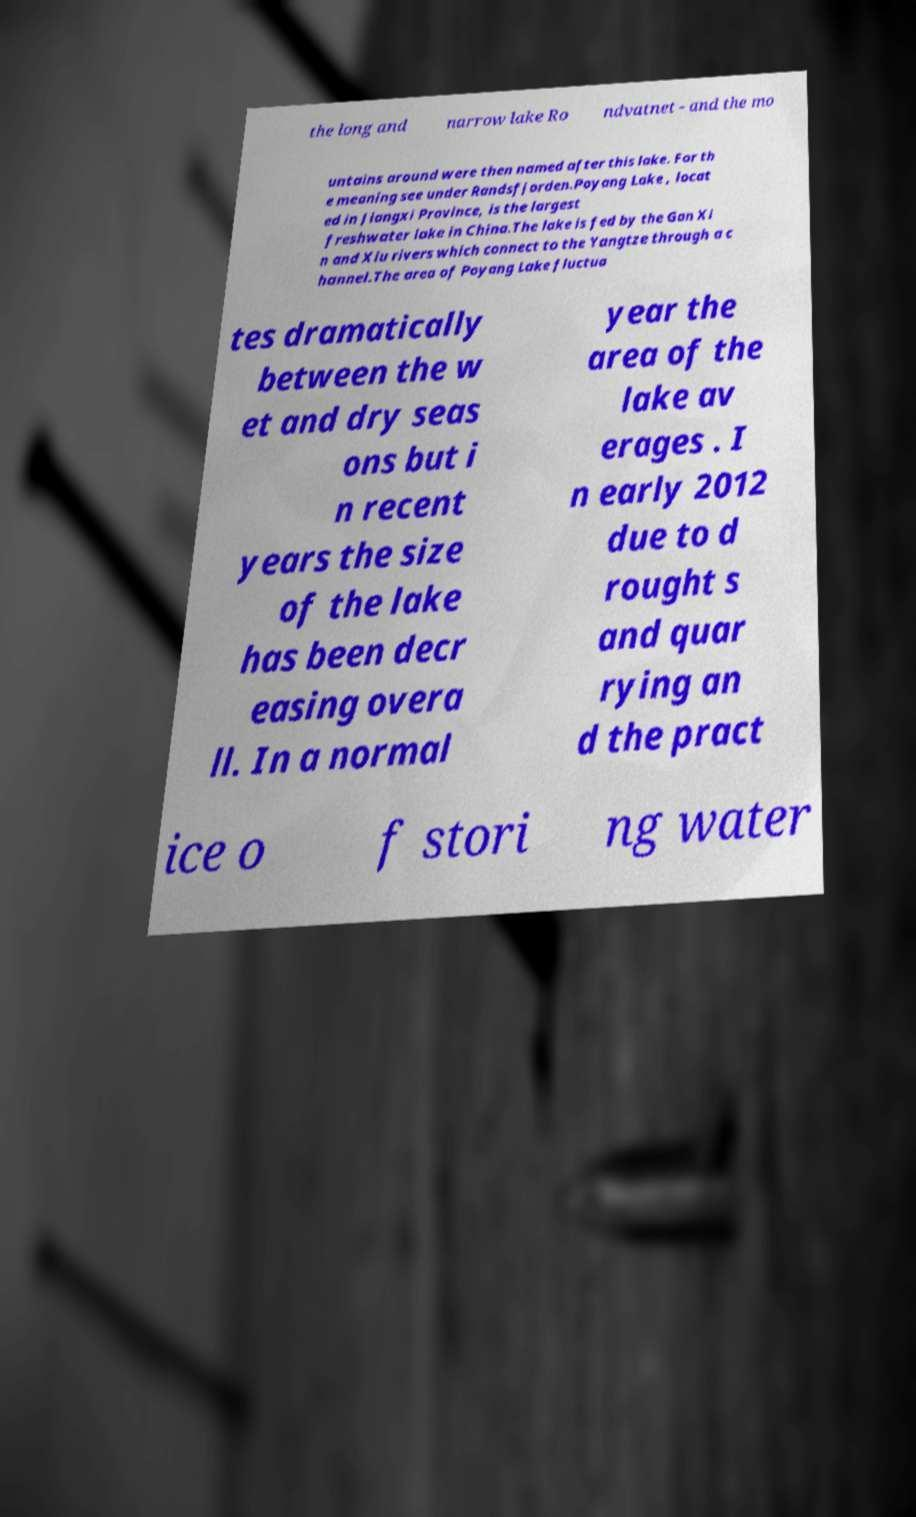What messages or text are displayed in this image? I need them in a readable, typed format. the long and narrow lake Ro ndvatnet - and the mo untains around were then named after this lake. For th e meaning see under Randsfjorden.Poyang Lake , locat ed in Jiangxi Province, is the largest freshwater lake in China.The lake is fed by the Gan Xi n and Xiu rivers which connect to the Yangtze through a c hannel.The area of Poyang Lake fluctua tes dramatically between the w et and dry seas ons but i n recent years the size of the lake has been decr easing overa ll. In a normal year the area of the lake av erages . I n early 2012 due to d rought s and quar rying an d the pract ice o f stori ng water 